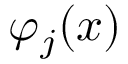Convert formula to latex. <formula><loc_0><loc_0><loc_500><loc_500>\varphi _ { j } ( x )</formula> 